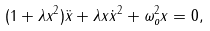<formula> <loc_0><loc_0><loc_500><loc_500>( 1 + \lambda x ^ { 2 } ) \ddot { x } + \lambda x \dot { x } ^ { 2 } + \omega _ { o } ^ { 2 } x = 0 ,</formula> 